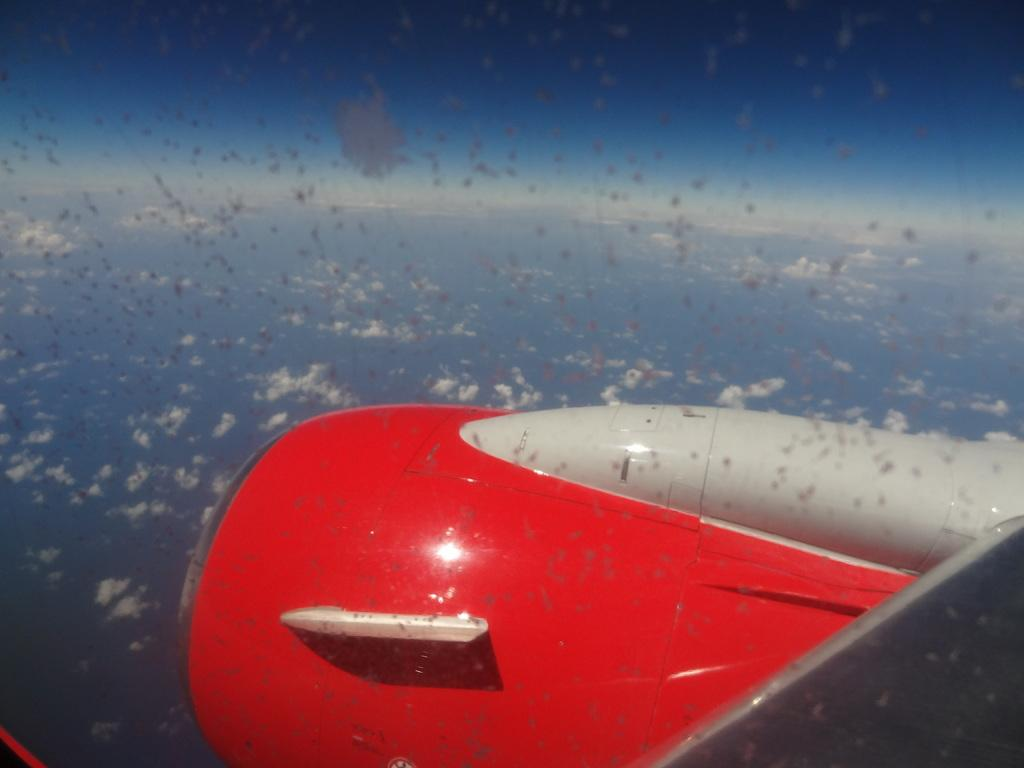What can be seen in the background of the image? The sky is visible in the image. What is the condition of the sky in the image? There are clouds in the sky. What is the main subject located towards the bottom of the image? There is an aircraft in the image, located towards the bottom. Where is the playground located in the image? There is no playground present in the image. What type of tin can be seen near the aircraft in the image? There is no tin present in the image. 